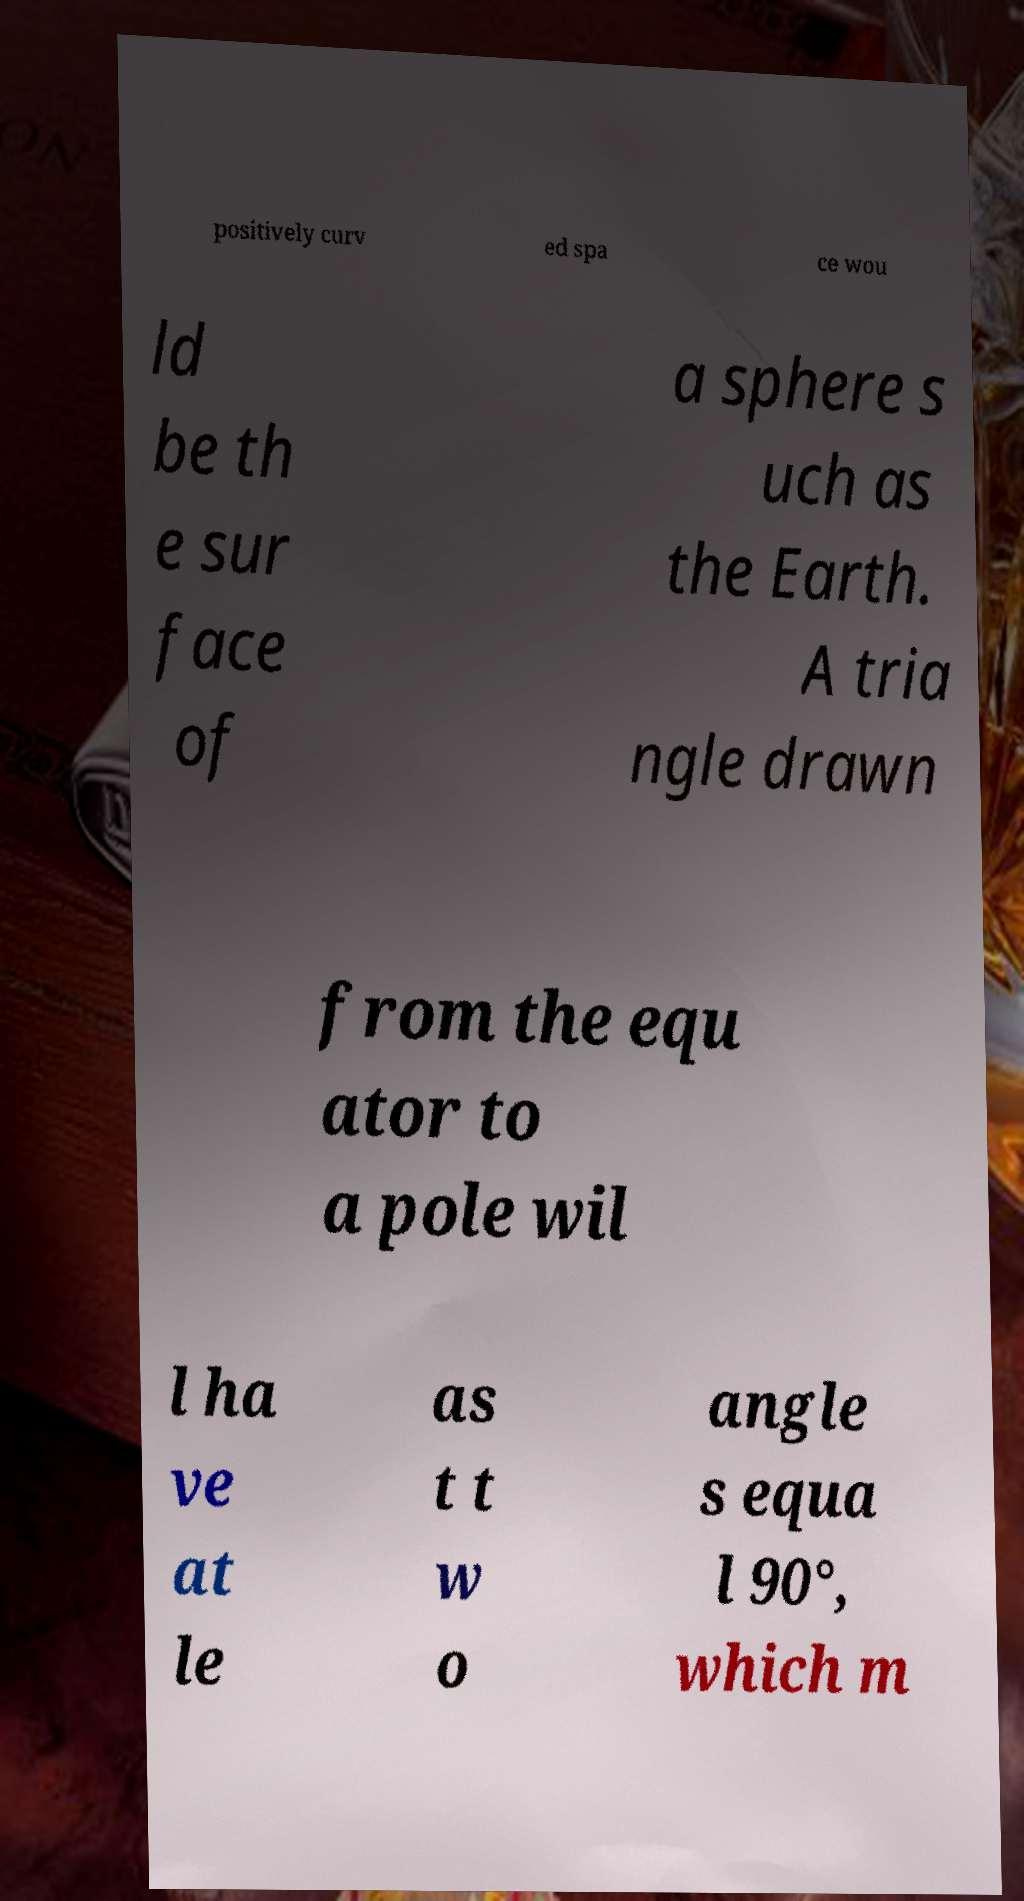Please read and relay the text visible in this image. What does it say? positively curv ed spa ce wou ld be th e sur face of a sphere s uch as the Earth. A tria ngle drawn from the equ ator to a pole wil l ha ve at le as t t w o angle s equa l 90°, which m 